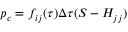Convert formula to latex. <formula><loc_0><loc_0><loc_500><loc_500>p _ { c } = f _ { i j } ( \tau ) \Delta \tau ( S - H _ { j j } )</formula> 